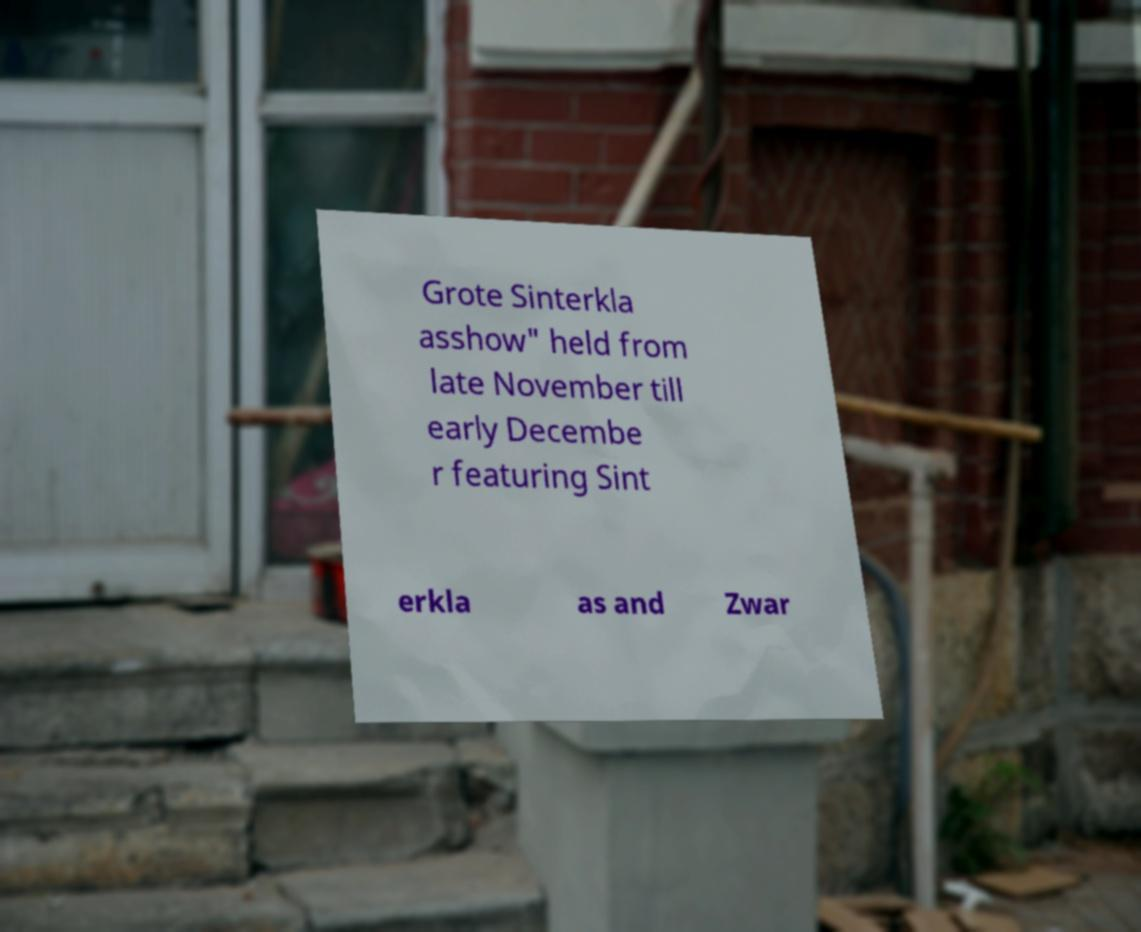Could you extract and type out the text from this image? Grote Sinterkla asshow" held from late November till early Decembe r featuring Sint erkla as and Zwar 